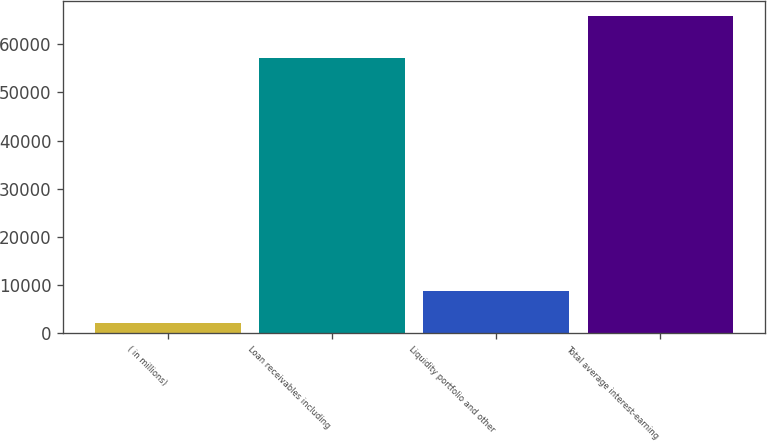Convert chart. <chart><loc_0><loc_0><loc_500><loc_500><bar_chart><fcel>( in millions)<fcel>Loan receivables including<fcel>Liquidity portfolio and other<fcel>Total average interest-earning<nl><fcel>2014<fcel>57101<fcel>8717<fcel>65818<nl></chart> 